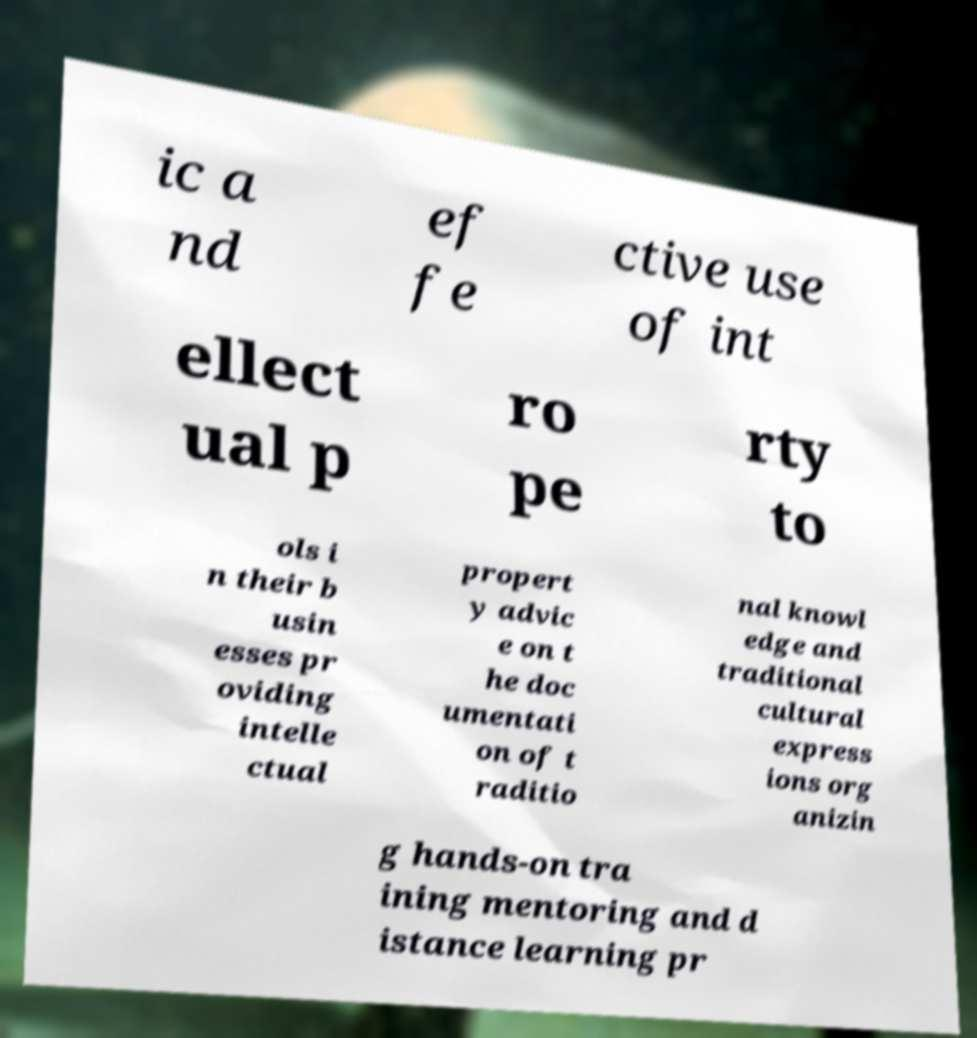Can you accurately transcribe the text from the provided image for me? ic a nd ef fe ctive use of int ellect ual p ro pe rty to ols i n their b usin esses pr oviding intelle ctual propert y advic e on t he doc umentati on of t raditio nal knowl edge and traditional cultural express ions org anizin g hands-on tra ining mentoring and d istance learning pr 